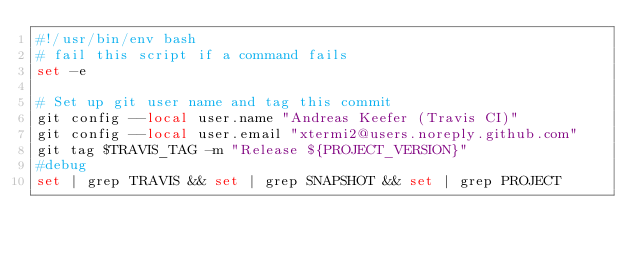<code> <loc_0><loc_0><loc_500><loc_500><_Bash_>#!/usr/bin/env bash
# fail this script if a command fails
set -e

# Set up git user name and tag this commit
git config --local user.name "Andreas Keefer (Travis CI)"
git config --local user.email "xtermi2@users.noreply.github.com"
git tag $TRAVIS_TAG -m "Release ${PROJECT_VERSION}"
#debug
set | grep TRAVIS && set | grep SNAPSHOT && set | grep PROJECT</code> 